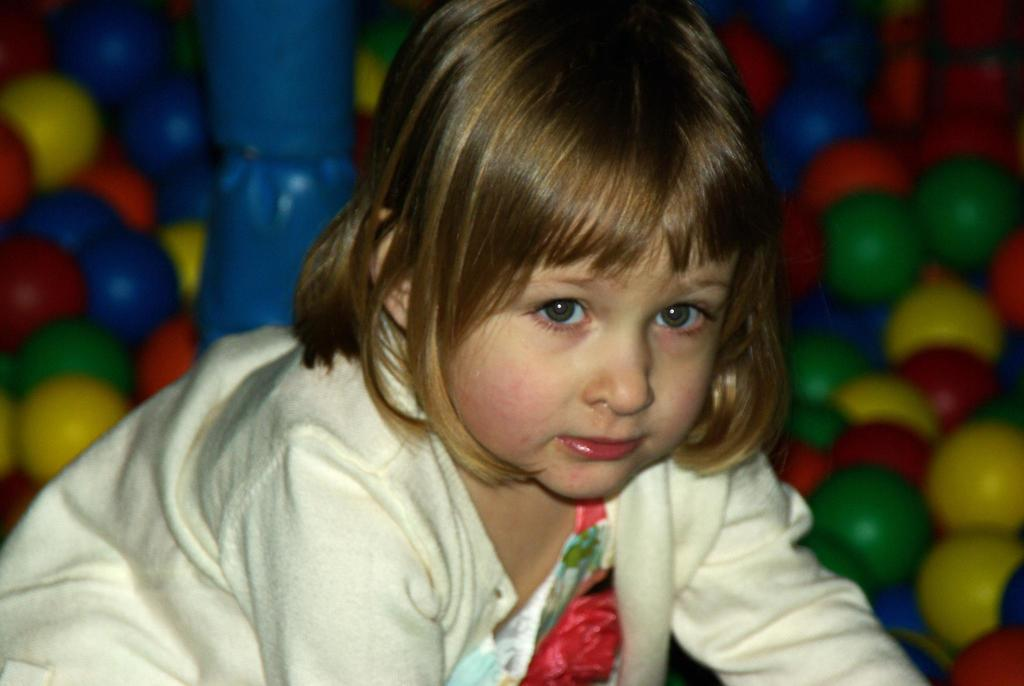What is the main subject of the image? There is a kid in the image. What can be seen in the background of the image? There are colored balls and a blue colored object in the background of the image. How does the pencil system work in the image? There is no pencil or system present in the image. What type of rub is being applied to the blue object in the image? There is no rubbing or any interaction with the blue object in the image. 